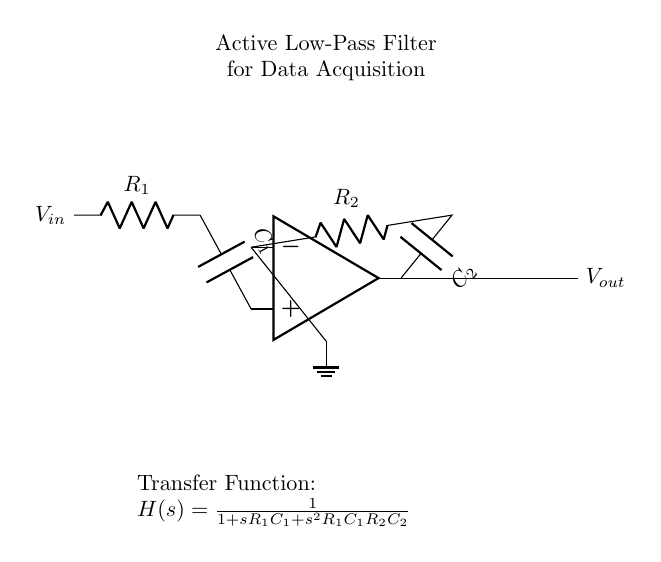what type of filter is this circuit designed for? The circuit is identified as a low-pass filter, which allows signals with a frequency lower than a certain cutoff frequency to pass through while attenuating higher frequencies. This can be deduced from the context that it is labeled "Active Low-Pass Filter" in the circuit diagram.
Answer: Low-pass filter what components are used in the feedback path? The components in the feedback path consist of a resistor and a capacitor: specifically, resistor two and capacitor two, labeled as R2 and C2. These components create a feedback loop that helps to shape the filter characteristics.
Answer: R2 and C2 what is the transfer function of this filter? The transfer function is given as H(s) = 1 / (1 + sR1C1 + s^2R1C1R2C2). This can be directly identified in the circuit diagram under the transfer function label, which outlines the relationship between the input and output signals in the filter.
Answer: H(s) = 1 / (1 + sR1C1 + s^2R1C1R2C2) how many capacitors are present in this circuit? There are two capacitors in this circuit, labeled as C1 and C2. This can be seen from the circuit diagram, where both capacitors are used in the signal path and feedback loop.
Answer: Two what role does the operational amplifier play in this circuit? The operational amplifier serves as the active component that amplifies the input signal and enables the active filter operation. It combines the input from the capacitors and resistors to control the output voltage, which is characteristic of active filters.
Answer: Signal amplification what is the relationship between R1, C1, and the cutoff frequency? R1 and C1 determine the cutoff frequency of the filter as they both influence the time constant; the cutoff frequency fc is given by fc = 1 / (2πR1C1). This shows how the values of these components directly affect the frequency response of the filter.
Answer: Directly affects cutoff frequency 